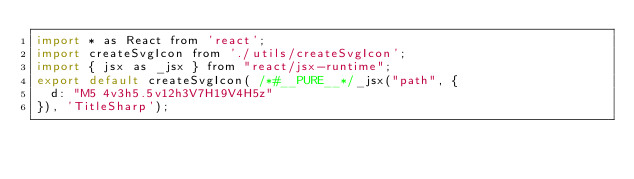Convert code to text. <code><loc_0><loc_0><loc_500><loc_500><_JavaScript_>import * as React from 'react';
import createSvgIcon from './utils/createSvgIcon';
import { jsx as _jsx } from "react/jsx-runtime";
export default createSvgIcon( /*#__PURE__*/_jsx("path", {
  d: "M5 4v3h5.5v12h3V7H19V4H5z"
}), 'TitleSharp');</code> 